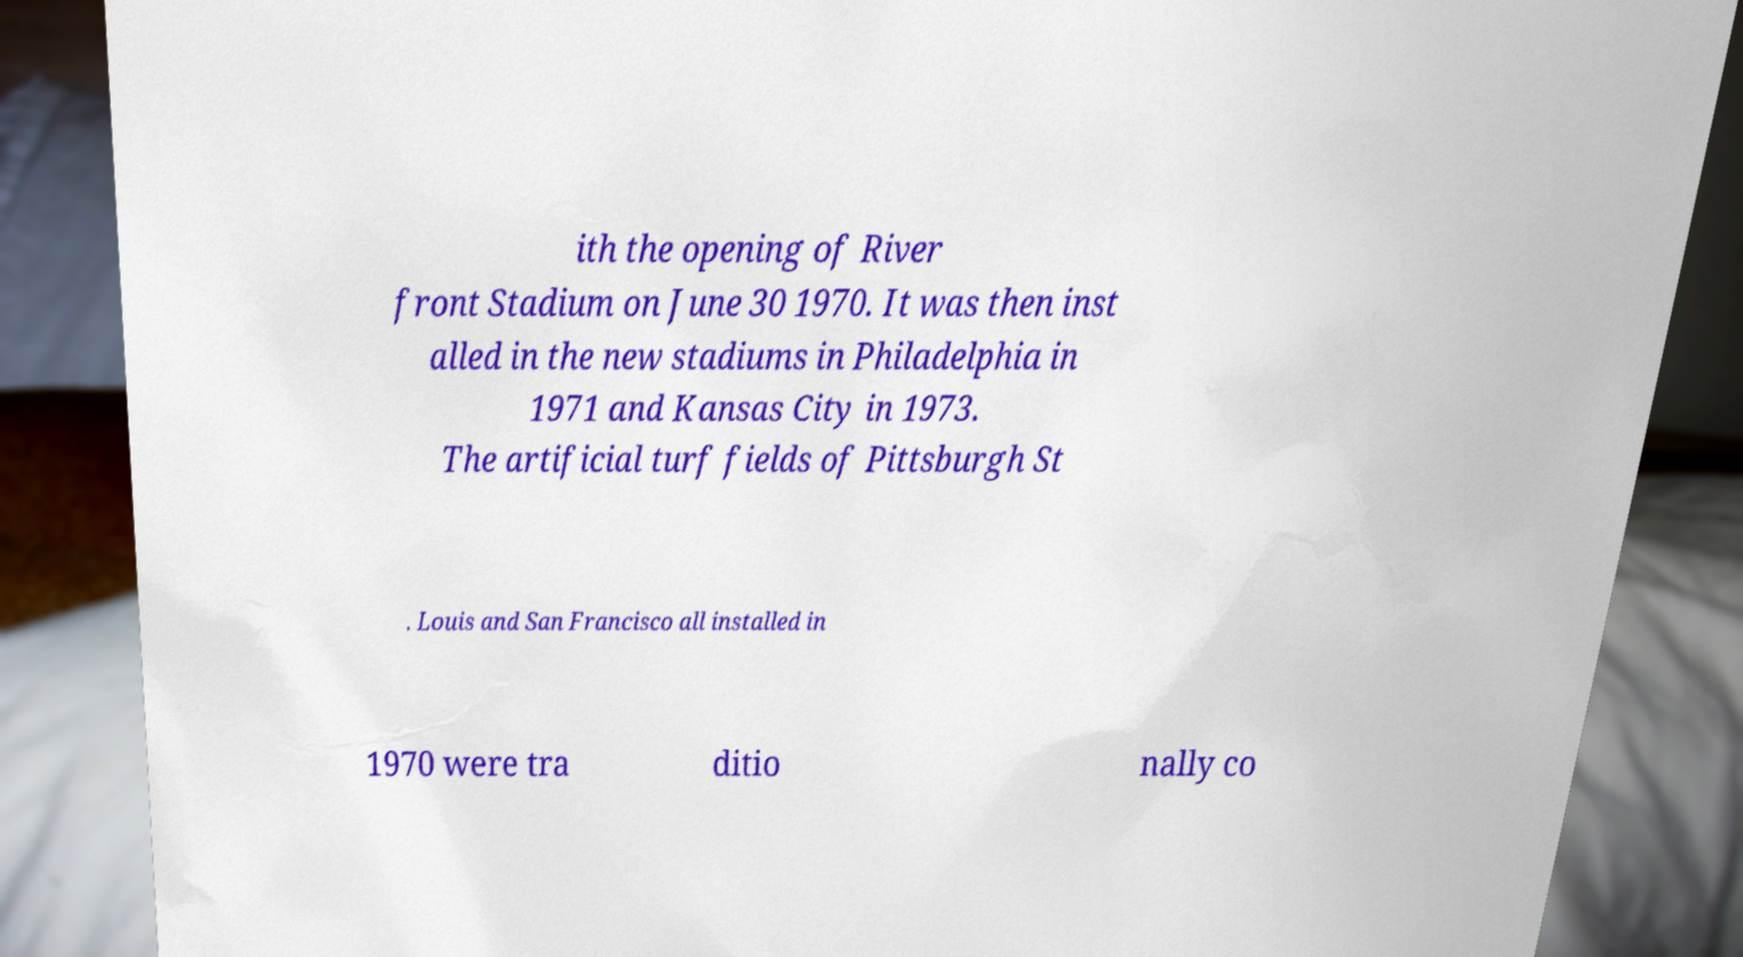Can you accurately transcribe the text from the provided image for me? ith the opening of River front Stadium on June 30 1970. It was then inst alled in the new stadiums in Philadelphia in 1971 and Kansas City in 1973. The artificial turf fields of Pittsburgh St . Louis and San Francisco all installed in 1970 were tra ditio nally co 